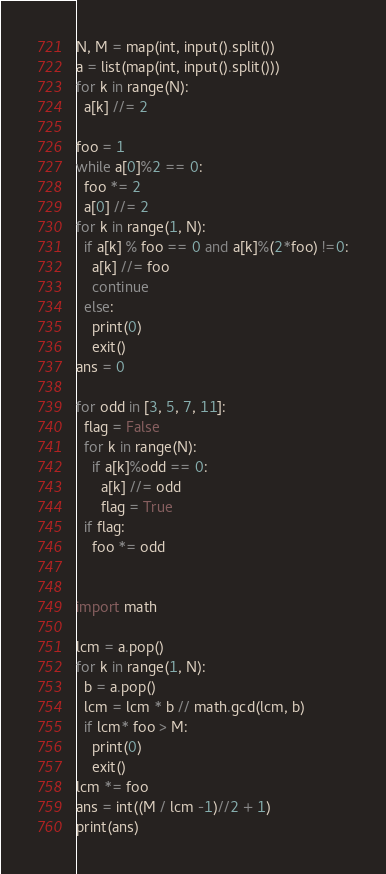Convert code to text. <code><loc_0><loc_0><loc_500><loc_500><_Python_>N, M = map(int, input().split())
a = list(map(int, input().split()))
for k in range(N):
  a[k] //= 2

foo = 1
while a[0]%2 == 0:
  foo *= 2
  a[0] //= 2
for k in range(1, N):
  if a[k] % foo == 0 and a[k]%(2*foo) !=0:
    a[k] //= foo
    continue
  else:
    print(0)
    exit()
ans = 0

for odd in [3, 5, 7, 11]:
  flag = False
  for k in range(N):
    if a[k]%odd == 0:
      a[k] //= odd
      flag = True
  if flag:
    foo *= odd
 
 
import math

lcm = a.pop()
for k in range(1, N):
  b = a.pop()
  lcm = lcm * b // math.gcd(lcm, b)
  if lcm* foo > M:
    print(0)
    exit()
lcm *= foo
ans = int((M / lcm -1)//2 + 1)
print(ans)</code> 